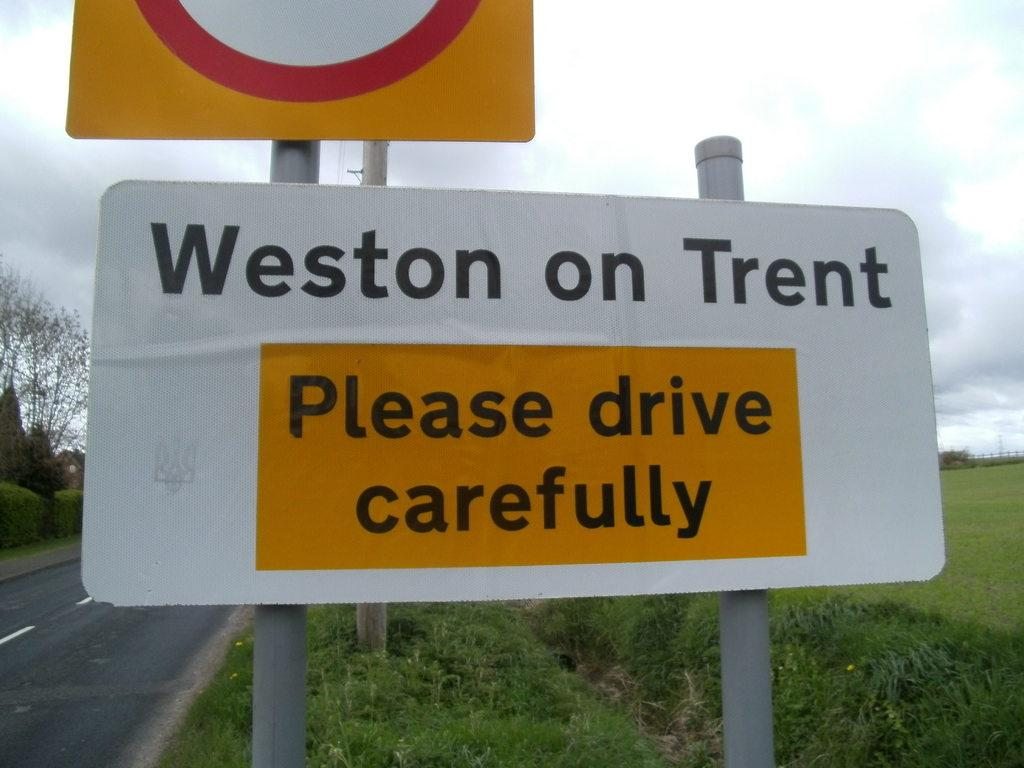<image>
Summarize the visual content of the image. The sign on the right side of the road asks motorists to please drive carefully. 